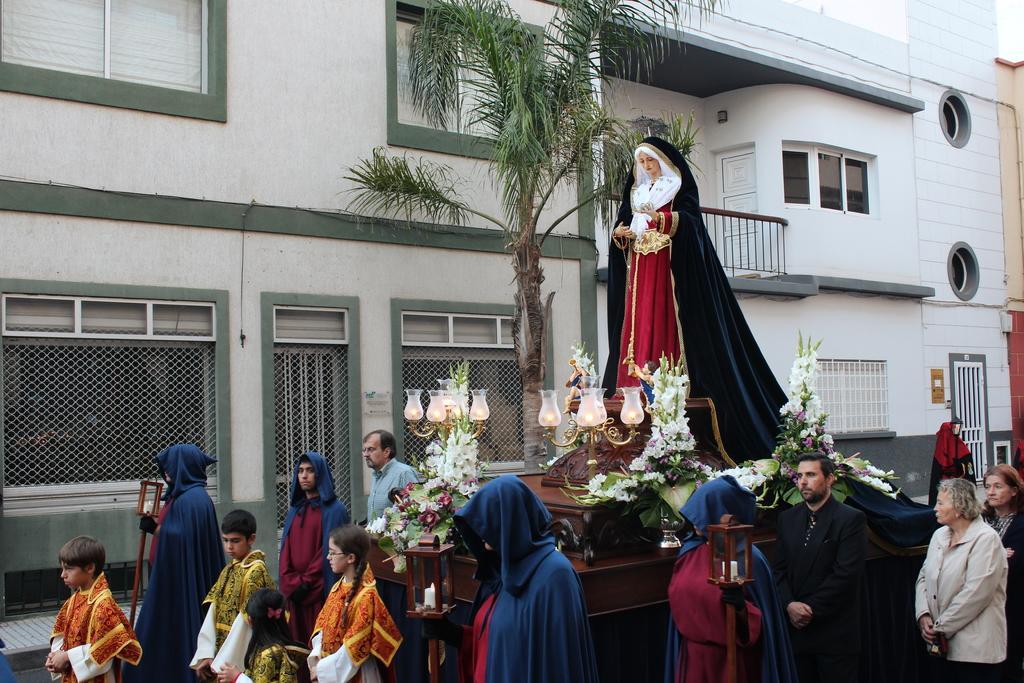Could you give a brief overview of what you see in this image? In this image I see number of people in which these 4 of them are wearing same dress and I see a brown color thing over here on which there is a depiction of a woman over here and I see the flowers and lights and in the background I see the buildings and I see a tree over here. 